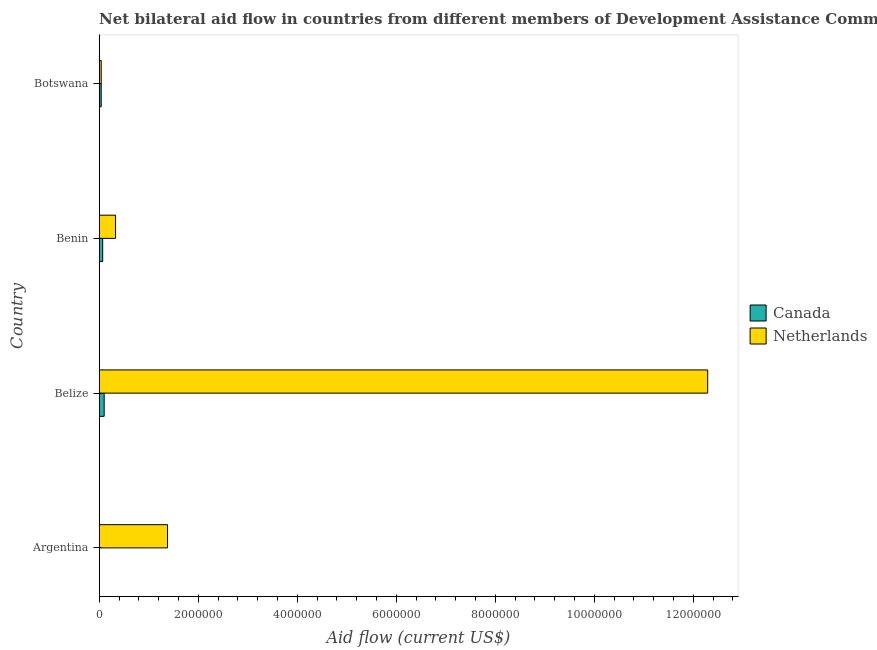Are the number of bars per tick equal to the number of legend labels?
Your response must be concise. No. Are the number of bars on each tick of the Y-axis equal?
Your answer should be very brief. No. How many bars are there on the 4th tick from the top?
Your answer should be compact. 1. How many bars are there on the 3rd tick from the bottom?
Keep it short and to the point. 2. What is the label of the 3rd group of bars from the top?
Your answer should be very brief. Belize. In how many cases, is the number of bars for a given country not equal to the number of legend labels?
Provide a succinct answer. 1. What is the amount of aid given by netherlands in Botswana?
Offer a very short reply. 4.00e+04. Across all countries, what is the maximum amount of aid given by netherlands?
Your answer should be very brief. 1.23e+07. Across all countries, what is the minimum amount of aid given by canada?
Offer a very short reply. 0. In which country was the amount of aid given by netherlands maximum?
Provide a short and direct response. Belize. What is the total amount of aid given by netherlands in the graph?
Keep it short and to the point. 1.40e+07. What is the difference between the amount of aid given by netherlands in Argentina and that in Belize?
Give a very brief answer. -1.09e+07. What is the difference between the amount of aid given by canada in Argentina and the amount of aid given by netherlands in Belize?
Keep it short and to the point. -1.23e+07. What is the average amount of aid given by canada per country?
Ensure brevity in your answer.  5.25e+04. Is the amount of aid given by canada in Benin less than that in Botswana?
Keep it short and to the point. No. What is the difference between the highest and the second highest amount of aid given by netherlands?
Provide a succinct answer. 1.09e+07. What is the difference between the highest and the lowest amount of aid given by netherlands?
Ensure brevity in your answer.  1.22e+07. Are all the bars in the graph horizontal?
Your answer should be very brief. Yes. How many countries are there in the graph?
Make the answer very short. 4. What is the difference between two consecutive major ticks on the X-axis?
Ensure brevity in your answer.  2.00e+06. Are the values on the major ticks of X-axis written in scientific E-notation?
Provide a succinct answer. No. Does the graph contain any zero values?
Offer a very short reply. Yes. Does the graph contain grids?
Offer a very short reply. No. How many legend labels are there?
Provide a short and direct response. 2. What is the title of the graph?
Your response must be concise. Net bilateral aid flow in countries from different members of Development Assistance Committee. Does "% of GNI" appear as one of the legend labels in the graph?
Give a very brief answer. No. What is the Aid flow (current US$) of Canada in Argentina?
Keep it short and to the point. 0. What is the Aid flow (current US$) in Netherlands in Argentina?
Offer a very short reply. 1.38e+06. What is the Aid flow (current US$) in Canada in Belize?
Your answer should be very brief. 1.00e+05. What is the Aid flow (current US$) in Netherlands in Belize?
Offer a very short reply. 1.23e+07. What is the Aid flow (current US$) in Canada in Benin?
Ensure brevity in your answer.  7.00e+04. What is the Aid flow (current US$) of Netherlands in Benin?
Your response must be concise. 3.30e+05. What is the Aid flow (current US$) of Netherlands in Botswana?
Make the answer very short. 4.00e+04. Across all countries, what is the maximum Aid flow (current US$) in Canada?
Provide a succinct answer. 1.00e+05. Across all countries, what is the maximum Aid flow (current US$) of Netherlands?
Your answer should be compact. 1.23e+07. Across all countries, what is the minimum Aid flow (current US$) in Canada?
Ensure brevity in your answer.  0. What is the total Aid flow (current US$) of Netherlands in the graph?
Offer a very short reply. 1.40e+07. What is the difference between the Aid flow (current US$) in Netherlands in Argentina and that in Belize?
Keep it short and to the point. -1.09e+07. What is the difference between the Aid flow (current US$) in Netherlands in Argentina and that in Benin?
Your answer should be compact. 1.05e+06. What is the difference between the Aid flow (current US$) in Netherlands in Argentina and that in Botswana?
Provide a short and direct response. 1.34e+06. What is the difference between the Aid flow (current US$) in Netherlands in Belize and that in Benin?
Provide a succinct answer. 1.20e+07. What is the difference between the Aid flow (current US$) of Netherlands in Belize and that in Botswana?
Keep it short and to the point. 1.22e+07. What is the difference between the Aid flow (current US$) in Canada in Benin and that in Botswana?
Keep it short and to the point. 3.00e+04. What is the difference between the Aid flow (current US$) of Netherlands in Benin and that in Botswana?
Make the answer very short. 2.90e+05. What is the difference between the Aid flow (current US$) of Canada in Belize and the Aid flow (current US$) of Netherlands in Benin?
Your response must be concise. -2.30e+05. What is the difference between the Aid flow (current US$) of Canada in Belize and the Aid flow (current US$) of Netherlands in Botswana?
Provide a short and direct response. 6.00e+04. What is the difference between the Aid flow (current US$) in Canada in Benin and the Aid flow (current US$) in Netherlands in Botswana?
Make the answer very short. 3.00e+04. What is the average Aid flow (current US$) of Canada per country?
Offer a very short reply. 5.25e+04. What is the average Aid flow (current US$) of Netherlands per country?
Ensure brevity in your answer.  3.51e+06. What is the difference between the Aid flow (current US$) of Canada and Aid flow (current US$) of Netherlands in Belize?
Offer a very short reply. -1.22e+07. What is the difference between the Aid flow (current US$) of Canada and Aid flow (current US$) of Netherlands in Benin?
Your answer should be compact. -2.60e+05. What is the ratio of the Aid flow (current US$) in Netherlands in Argentina to that in Belize?
Provide a succinct answer. 0.11. What is the ratio of the Aid flow (current US$) in Netherlands in Argentina to that in Benin?
Provide a succinct answer. 4.18. What is the ratio of the Aid flow (current US$) of Netherlands in Argentina to that in Botswana?
Keep it short and to the point. 34.5. What is the ratio of the Aid flow (current US$) of Canada in Belize to that in Benin?
Provide a short and direct response. 1.43. What is the ratio of the Aid flow (current US$) in Netherlands in Belize to that in Benin?
Provide a succinct answer. 37.24. What is the ratio of the Aid flow (current US$) in Canada in Belize to that in Botswana?
Make the answer very short. 2.5. What is the ratio of the Aid flow (current US$) in Netherlands in Belize to that in Botswana?
Keep it short and to the point. 307.25. What is the ratio of the Aid flow (current US$) of Canada in Benin to that in Botswana?
Give a very brief answer. 1.75. What is the ratio of the Aid flow (current US$) in Netherlands in Benin to that in Botswana?
Offer a terse response. 8.25. What is the difference between the highest and the second highest Aid flow (current US$) of Netherlands?
Provide a succinct answer. 1.09e+07. What is the difference between the highest and the lowest Aid flow (current US$) in Canada?
Keep it short and to the point. 1.00e+05. What is the difference between the highest and the lowest Aid flow (current US$) of Netherlands?
Your answer should be compact. 1.22e+07. 